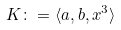<formula> <loc_0><loc_0><loc_500><loc_500>K \colon = \langle a , b , x ^ { 3 } \rangle</formula> 